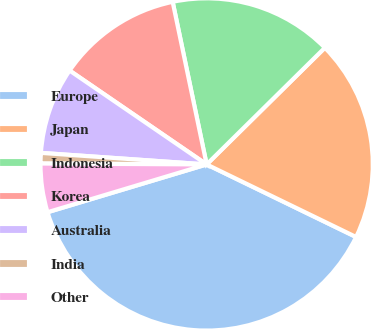<chart> <loc_0><loc_0><loc_500><loc_500><pie_chart><fcel>Europe<fcel>Japan<fcel>Indonesia<fcel>Korea<fcel>Australia<fcel>India<fcel>Other<nl><fcel>38.16%<fcel>19.59%<fcel>15.88%<fcel>12.16%<fcel>8.45%<fcel>1.02%<fcel>4.73%<nl></chart> 